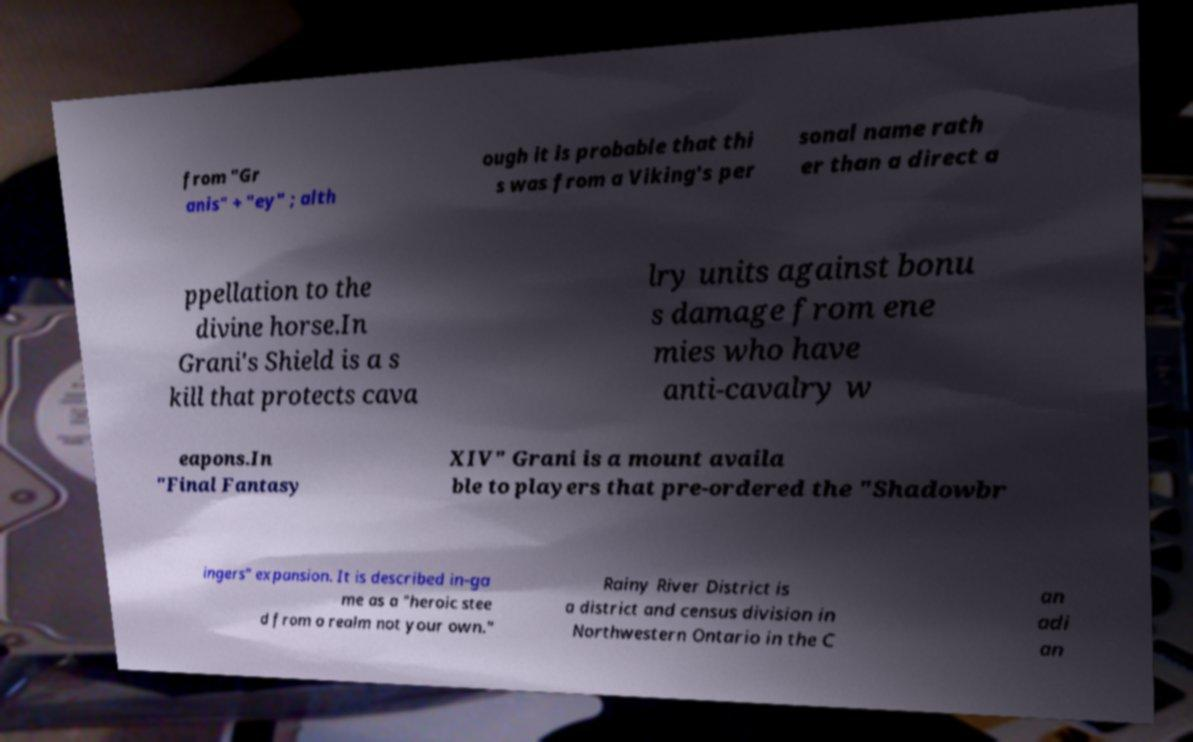Please identify and transcribe the text found in this image. from "Gr anis" + "ey" ; alth ough it is probable that thi s was from a Viking's per sonal name rath er than a direct a ppellation to the divine horse.In Grani's Shield is a s kill that protects cava lry units against bonu s damage from ene mies who have anti-cavalry w eapons.In "Final Fantasy XIV" Grani is a mount availa ble to players that pre-ordered the "Shadowbr ingers" expansion. It is described in-ga me as a "heroic stee d from a realm not your own." Rainy River District is a district and census division in Northwestern Ontario in the C an adi an 